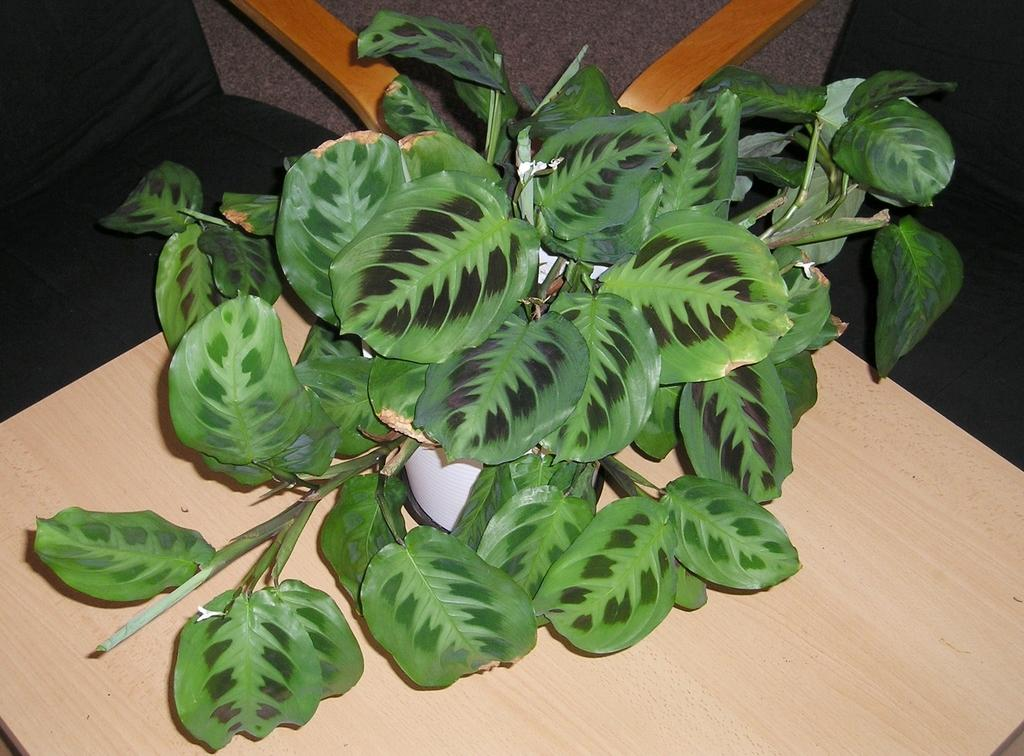What is in the pot that is visible in the image? There is a plant in a pot in the image. Where is the pot located in the image? The pot is placed on a table. What else can be seen in the image besides the plant and pot? There are chairs visible at the top of the image. How many oranges are on the table next to the plant? There are no oranges visible in the image; only a plant in a pot and chairs are present. 